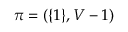Convert formula to latex. <formula><loc_0><loc_0><loc_500><loc_500>\pi = ( \{ 1 \} , V - 1 )</formula> 